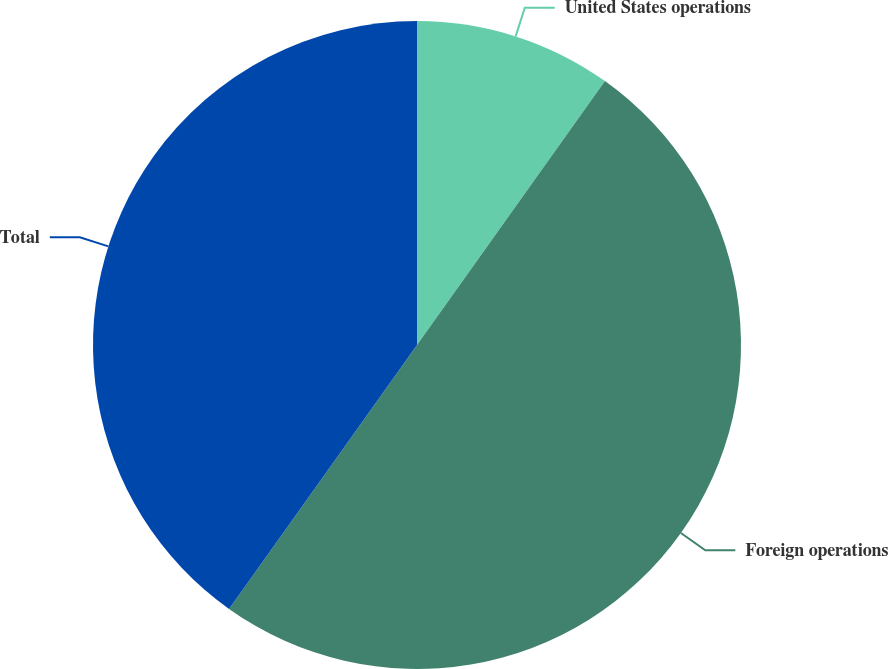<chart> <loc_0><loc_0><loc_500><loc_500><pie_chart><fcel>United States operations<fcel>Foreign operations<fcel>Total<nl><fcel>9.85%<fcel>50.0%<fcel>40.15%<nl></chart> 